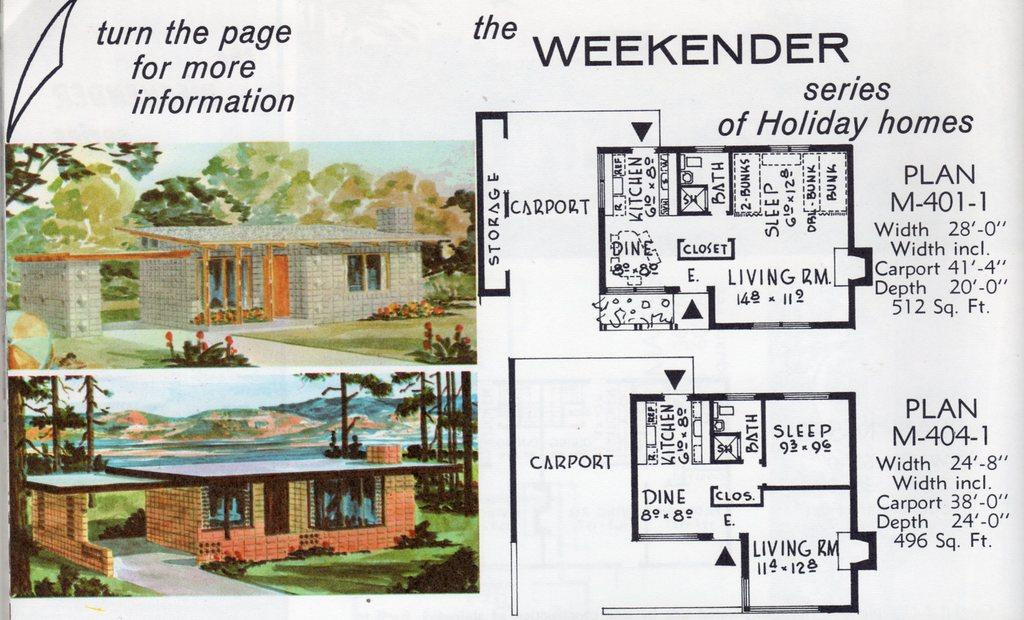Provide a one-sentence caption for the provided image. An illustration details floor plans for a housing development called the Weekender. 